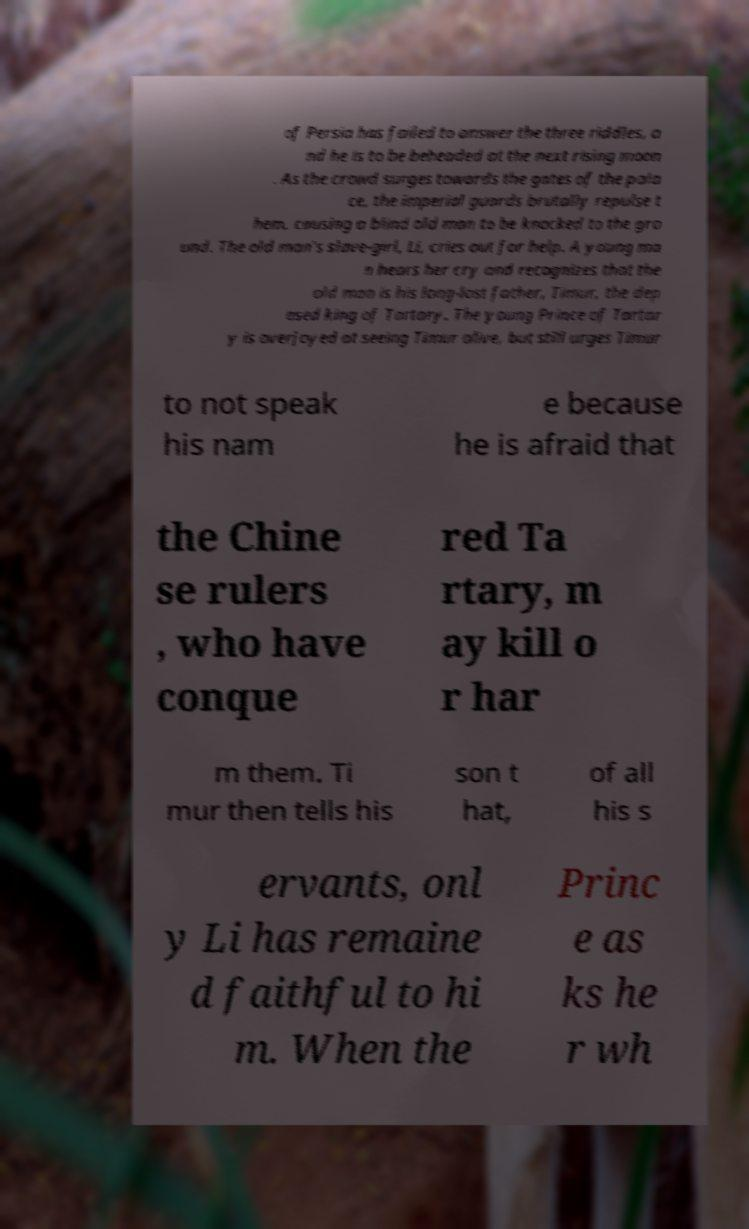Could you extract and type out the text from this image? of Persia has failed to answer the three riddles, a nd he is to be beheaded at the next rising moon . As the crowd surges towards the gates of the pala ce, the imperial guards brutally repulse t hem, causing a blind old man to be knocked to the gro und. The old man's slave-girl, Li, cries out for help. A young ma n hears her cry and recognizes that the old man is his long-lost father, Timur, the dep osed king of Tartary. The young Prince of Tartar y is overjoyed at seeing Timur alive, but still urges Timur to not speak his nam e because he is afraid that the Chine se rulers , who have conque red Ta rtary, m ay kill o r har m them. Ti mur then tells his son t hat, of all his s ervants, onl y Li has remaine d faithful to hi m. When the Princ e as ks he r wh 